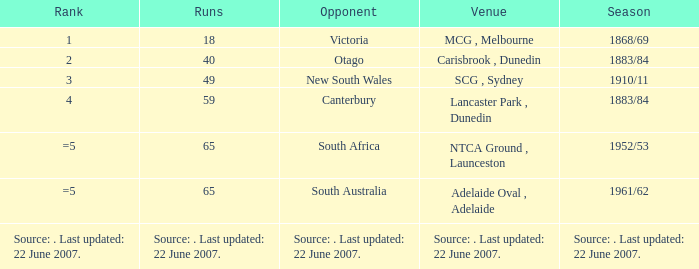Which Runs has a Opponent of south australia? 65.0. 